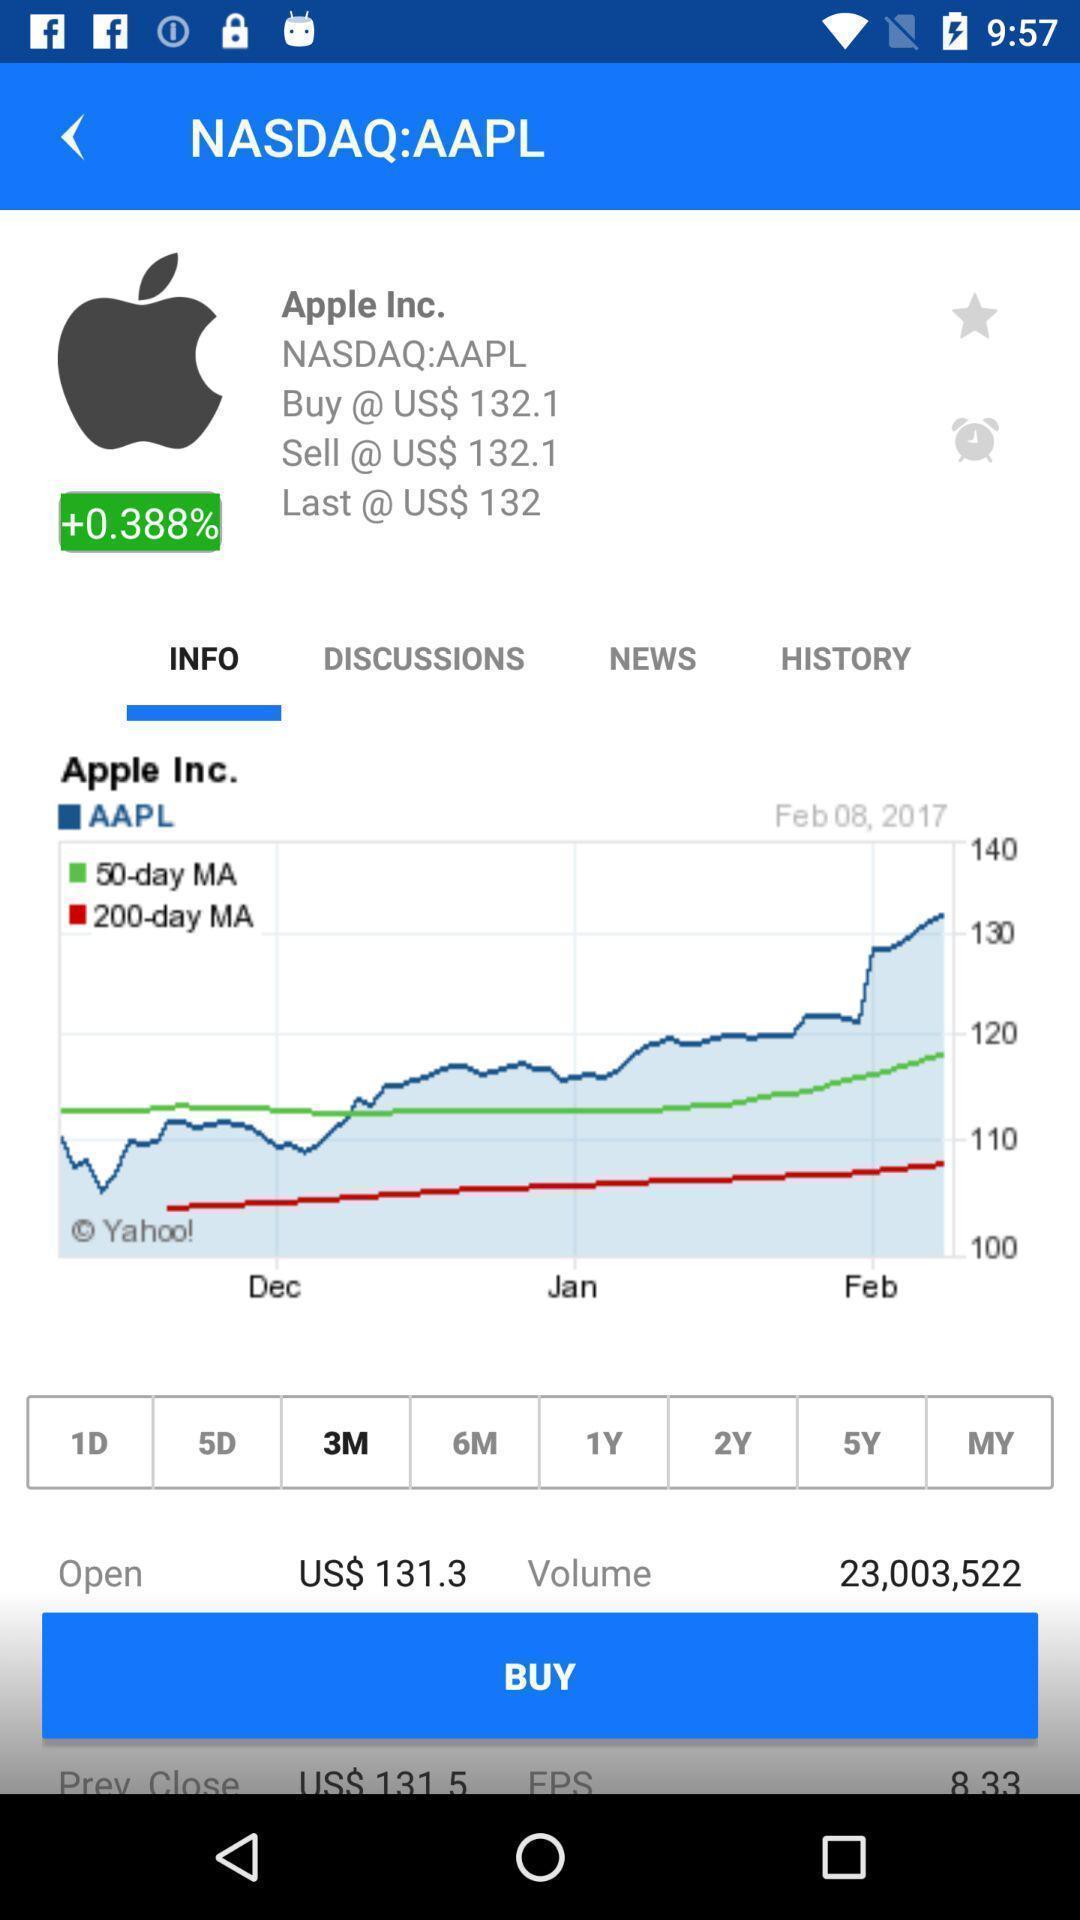What is the overall content of this screenshot? Screen displaying multiple options and information about the mobile application. 